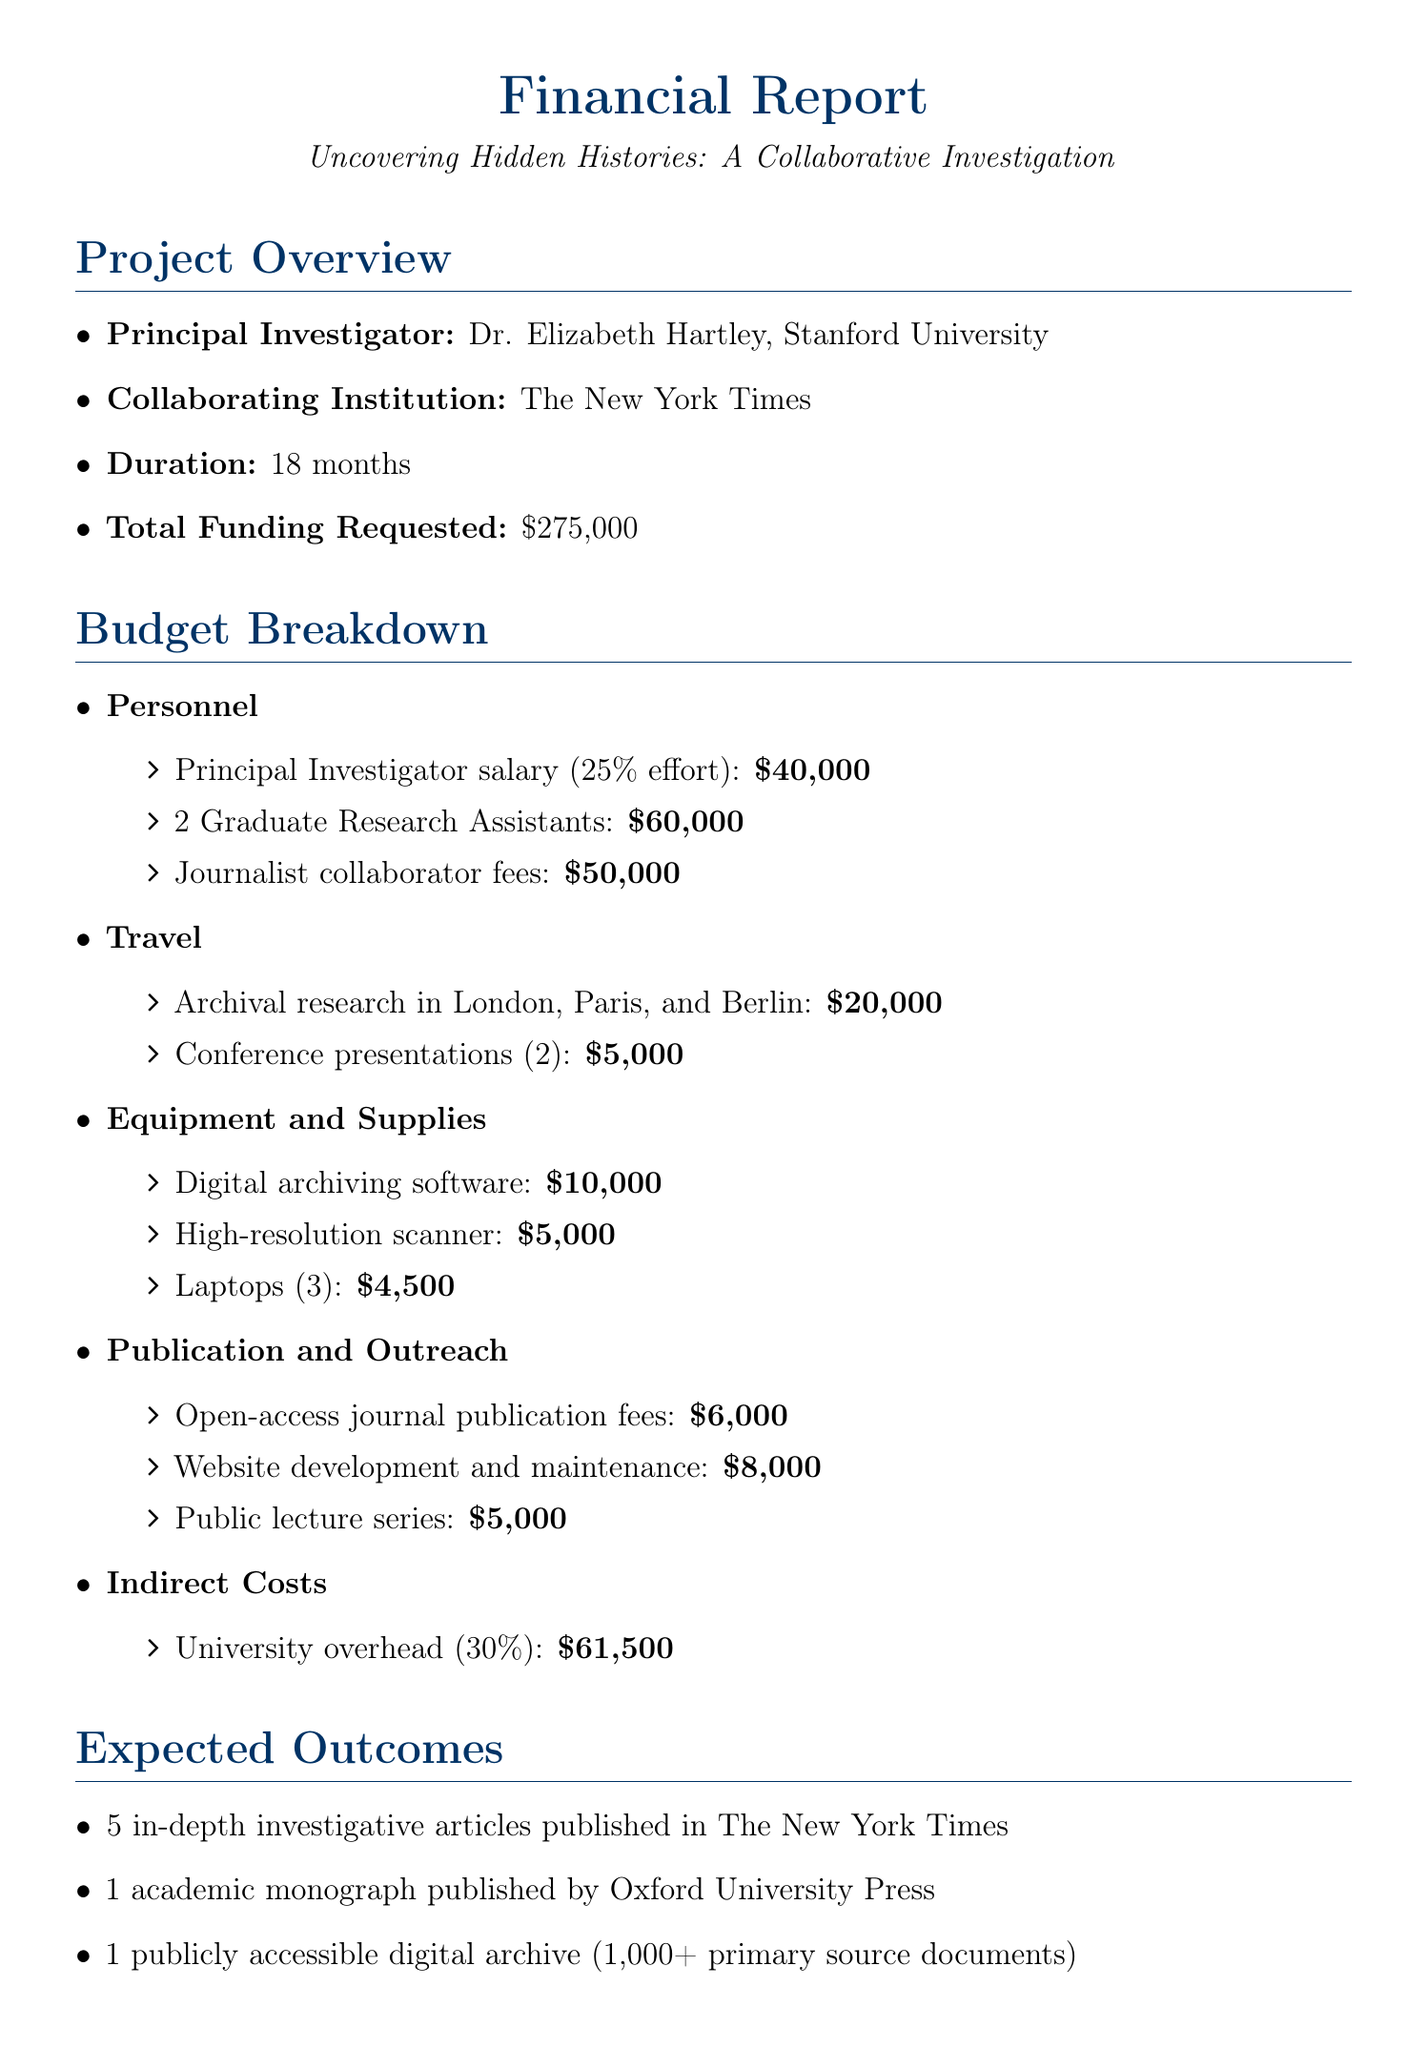What is the project title? The project title is listed at the beginning of the document as the main focus of the report.
Answer: Uncovering Hidden Histories: A Collaborative Investigation Who is the principal investigator? The principal investigator's name and title are provided in the project overview section.
Answer: Dr. Elizabeth Hartley What is the total funding requested? The total funding requested is clearly indicated in the project overview.
Answer: $275,000 How many graduate research assistants are funded? The number of graduate research assistants is specified in the personnel budget breakdown.
Answer: 2 What is the duration of the project? The duration of the project is mentioned early in the project overview section.
Answer: 18 months What is the budget for travel? The travel category includes specific amounts allocated for travel-related activities in the budget breakdown.
Answer: $25,000 What is the expected number of investigative articles to be published in The New York Times? The expected outcomes section lists the anticipated number of articles to be published.
Answer: 5 What institutional support is provided for the project? The document outlines the institutional support in the conclusion, specifying what Stanford University will provide.
Answer: office space, library access, and administrative support What is the category with the highest budget allocation? By examining the budget breakdown, you can identify which category has the highest total cost.
Answer: Indirect Costs 